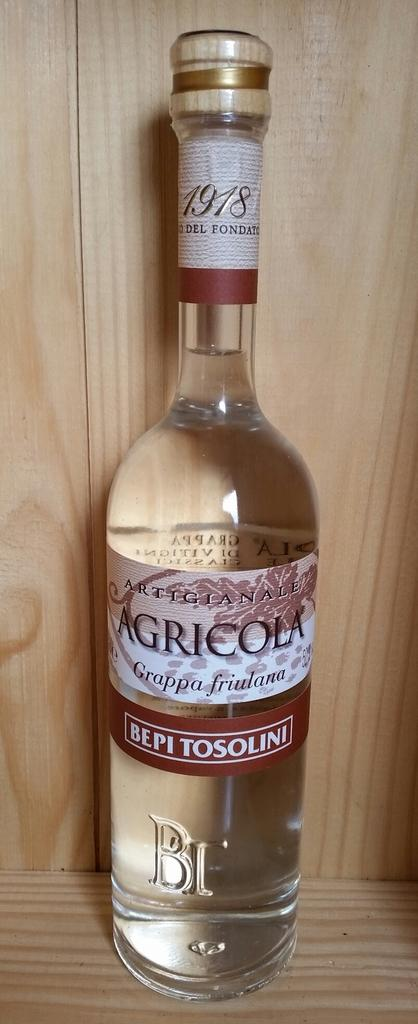<image>
Write a terse but informative summary of the picture. A bottle of Agricola Grappa Fruilana in a clear bottle \] 